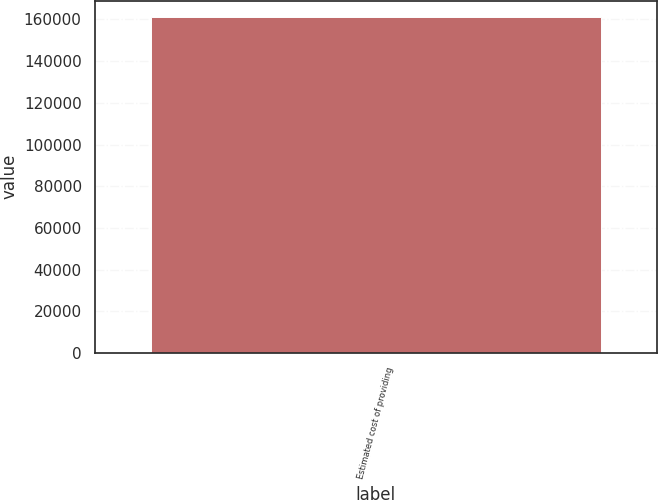Convert chart. <chart><loc_0><loc_0><loc_500><loc_500><bar_chart><fcel>Estimated cost of providing<nl><fcel>161013<nl></chart> 